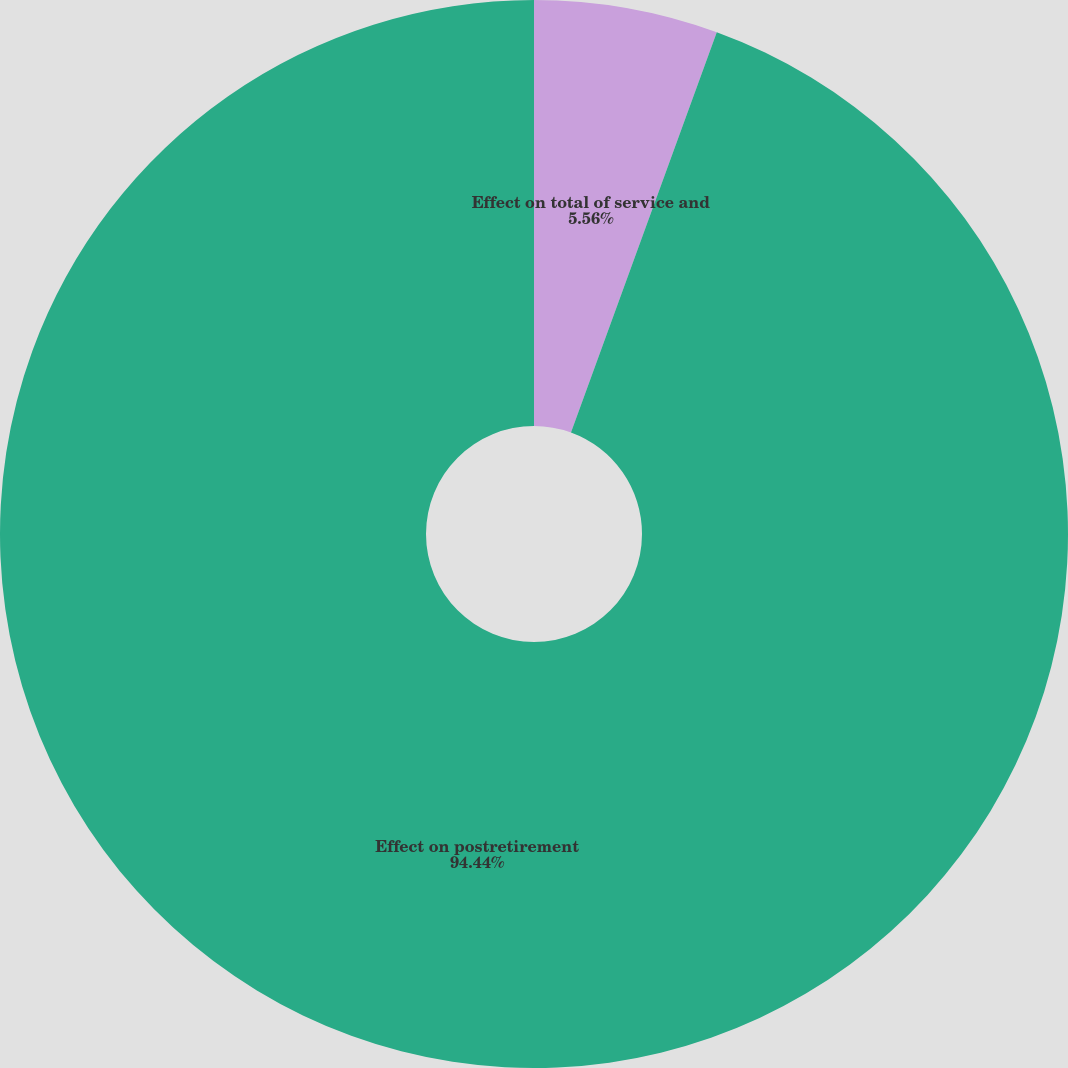Convert chart to OTSL. <chart><loc_0><loc_0><loc_500><loc_500><pie_chart><fcel>Effect on total of service and<fcel>Effect on postretirement<nl><fcel>5.56%<fcel>94.44%<nl></chart> 